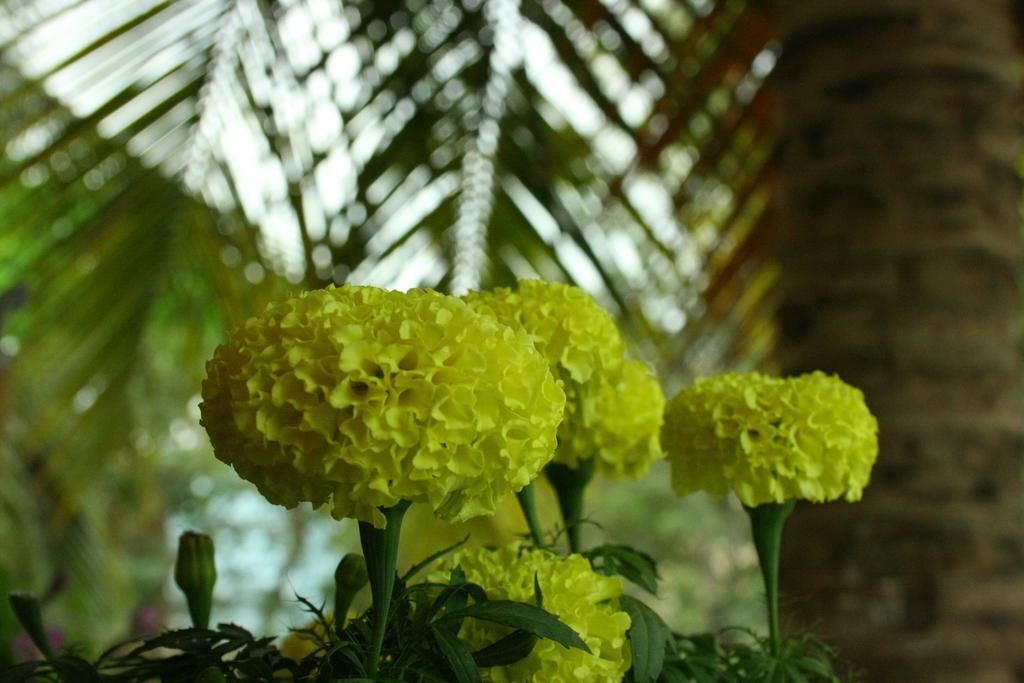How would you summarize this image in a sentence or two? In this picture I can observe flowers in the middle of the picture. In the background I can observe some trees. 